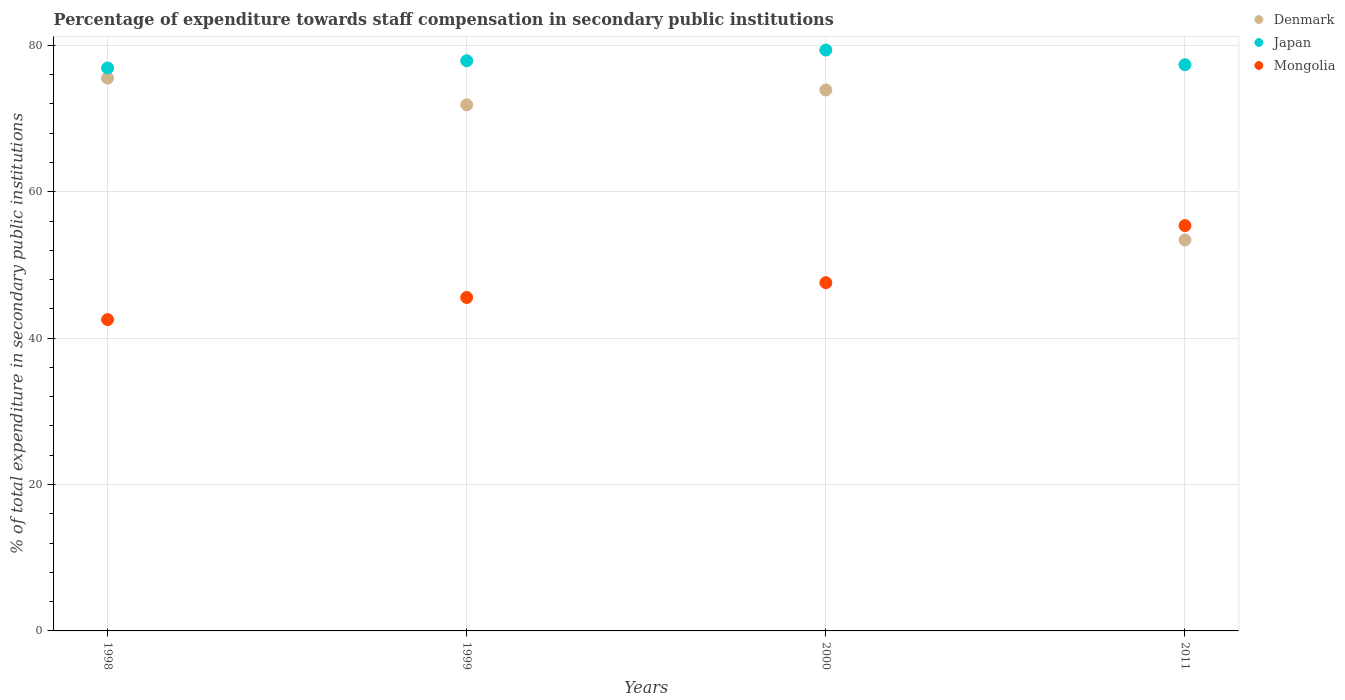What is the percentage of expenditure towards staff compensation in Denmark in 2011?
Keep it short and to the point. 53.42. Across all years, what is the maximum percentage of expenditure towards staff compensation in Mongolia?
Make the answer very short. 55.37. Across all years, what is the minimum percentage of expenditure towards staff compensation in Mongolia?
Offer a terse response. 42.53. What is the total percentage of expenditure towards staff compensation in Mongolia in the graph?
Your answer should be compact. 191.03. What is the difference between the percentage of expenditure towards staff compensation in Japan in 2000 and that in 2011?
Give a very brief answer. 2. What is the difference between the percentage of expenditure towards staff compensation in Mongolia in 1999 and the percentage of expenditure towards staff compensation in Denmark in 2000?
Your response must be concise. -28.35. What is the average percentage of expenditure towards staff compensation in Mongolia per year?
Provide a succinct answer. 47.76. In the year 2011, what is the difference between the percentage of expenditure towards staff compensation in Mongolia and percentage of expenditure towards staff compensation in Japan?
Your response must be concise. -21.99. In how many years, is the percentage of expenditure towards staff compensation in Denmark greater than 8 %?
Your response must be concise. 4. What is the ratio of the percentage of expenditure towards staff compensation in Japan in 1999 to that in 2011?
Ensure brevity in your answer.  1.01. Is the percentage of expenditure towards staff compensation in Japan in 1998 less than that in 1999?
Make the answer very short. Yes. Is the difference between the percentage of expenditure towards staff compensation in Mongolia in 1998 and 1999 greater than the difference between the percentage of expenditure towards staff compensation in Japan in 1998 and 1999?
Offer a very short reply. No. What is the difference between the highest and the second highest percentage of expenditure towards staff compensation in Denmark?
Keep it short and to the point. 1.62. What is the difference between the highest and the lowest percentage of expenditure towards staff compensation in Mongolia?
Give a very brief answer. 12.84. In how many years, is the percentage of expenditure towards staff compensation in Mongolia greater than the average percentage of expenditure towards staff compensation in Mongolia taken over all years?
Offer a terse response. 1. Is the sum of the percentage of expenditure towards staff compensation in Denmark in 1998 and 2000 greater than the maximum percentage of expenditure towards staff compensation in Mongolia across all years?
Provide a succinct answer. Yes. Is it the case that in every year, the sum of the percentage of expenditure towards staff compensation in Mongolia and percentage of expenditure towards staff compensation in Denmark  is greater than the percentage of expenditure towards staff compensation in Japan?
Keep it short and to the point. Yes. Does the percentage of expenditure towards staff compensation in Mongolia monotonically increase over the years?
Your answer should be very brief. Yes. Is the percentage of expenditure towards staff compensation in Japan strictly greater than the percentage of expenditure towards staff compensation in Mongolia over the years?
Provide a succinct answer. Yes. Is the percentage of expenditure towards staff compensation in Denmark strictly less than the percentage of expenditure towards staff compensation in Mongolia over the years?
Keep it short and to the point. No. How many years are there in the graph?
Keep it short and to the point. 4. Does the graph contain grids?
Your answer should be compact. Yes. What is the title of the graph?
Provide a succinct answer. Percentage of expenditure towards staff compensation in secondary public institutions. Does "Georgia" appear as one of the legend labels in the graph?
Offer a terse response. No. What is the label or title of the Y-axis?
Provide a succinct answer. % of total expenditure in secondary public institutions. What is the % of total expenditure in secondary public institutions in Denmark in 1998?
Your response must be concise. 75.52. What is the % of total expenditure in secondary public institutions in Japan in 1998?
Ensure brevity in your answer.  76.91. What is the % of total expenditure in secondary public institutions of Mongolia in 1998?
Give a very brief answer. 42.53. What is the % of total expenditure in secondary public institutions of Denmark in 1999?
Your answer should be very brief. 71.87. What is the % of total expenditure in secondary public institutions in Japan in 1999?
Make the answer very short. 77.89. What is the % of total expenditure in secondary public institutions in Mongolia in 1999?
Provide a short and direct response. 45.55. What is the % of total expenditure in secondary public institutions of Denmark in 2000?
Offer a very short reply. 73.9. What is the % of total expenditure in secondary public institutions of Japan in 2000?
Your response must be concise. 79.36. What is the % of total expenditure in secondary public institutions in Mongolia in 2000?
Your answer should be compact. 47.57. What is the % of total expenditure in secondary public institutions in Denmark in 2011?
Make the answer very short. 53.42. What is the % of total expenditure in secondary public institutions in Japan in 2011?
Offer a terse response. 77.36. What is the % of total expenditure in secondary public institutions in Mongolia in 2011?
Offer a terse response. 55.37. Across all years, what is the maximum % of total expenditure in secondary public institutions of Denmark?
Offer a very short reply. 75.52. Across all years, what is the maximum % of total expenditure in secondary public institutions in Japan?
Give a very brief answer. 79.36. Across all years, what is the maximum % of total expenditure in secondary public institutions of Mongolia?
Provide a short and direct response. 55.37. Across all years, what is the minimum % of total expenditure in secondary public institutions of Denmark?
Offer a terse response. 53.42. Across all years, what is the minimum % of total expenditure in secondary public institutions in Japan?
Make the answer very short. 76.91. Across all years, what is the minimum % of total expenditure in secondary public institutions in Mongolia?
Your answer should be compact. 42.53. What is the total % of total expenditure in secondary public institutions in Denmark in the graph?
Your response must be concise. 274.71. What is the total % of total expenditure in secondary public institutions in Japan in the graph?
Your answer should be very brief. 311.52. What is the total % of total expenditure in secondary public institutions in Mongolia in the graph?
Offer a very short reply. 191.03. What is the difference between the % of total expenditure in secondary public institutions of Denmark in 1998 and that in 1999?
Offer a very short reply. 3.65. What is the difference between the % of total expenditure in secondary public institutions of Japan in 1998 and that in 1999?
Offer a very short reply. -0.98. What is the difference between the % of total expenditure in secondary public institutions in Mongolia in 1998 and that in 1999?
Provide a succinct answer. -3.02. What is the difference between the % of total expenditure in secondary public institutions in Denmark in 1998 and that in 2000?
Your response must be concise. 1.62. What is the difference between the % of total expenditure in secondary public institutions of Japan in 1998 and that in 2000?
Give a very brief answer. -2.44. What is the difference between the % of total expenditure in secondary public institutions of Mongolia in 1998 and that in 2000?
Provide a succinct answer. -5.04. What is the difference between the % of total expenditure in secondary public institutions in Denmark in 1998 and that in 2011?
Make the answer very short. 22.11. What is the difference between the % of total expenditure in secondary public institutions of Japan in 1998 and that in 2011?
Give a very brief answer. -0.45. What is the difference between the % of total expenditure in secondary public institutions in Mongolia in 1998 and that in 2011?
Your response must be concise. -12.84. What is the difference between the % of total expenditure in secondary public institutions in Denmark in 1999 and that in 2000?
Give a very brief answer. -2.03. What is the difference between the % of total expenditure in secondary public institutions of Japan in 1999 and that in 2000?
Provide a succinct answer. -1.46. What is the difference between the % of total expenditure in secondary public institutions in Mongolia in 1999 and that in 2000?
Keep it short and to the point. -2.02. What is the difference between the % of total expenditure in secondary public institutions of Denmark in 1999 and that in 2011?
Provide a succinct answer. 18.46. What is the difference between the % of total expenditure in secondary public institutions of Japan in 1999 and that in 2011?
Keep it short and to the point. 0.53. What is the difference between the % of total expenditure in secondary public institutions of Mongolia in 1999 and that in 2011?
Give a very brief answer. -9.82. What is the difference between the % of total expenditure in secondary public institutions in Denmark in 2000 and that in 2011?
Make the answer very short. 20.49. What is the difference between the % of total expenditure in secondary public institutions of Japan in 2000 and that in 2011?
Make the answer very short. 2. What is the difference between the % of total expenditure in secondary public institutions of Mongolia in 2000 and that in 2011?
Your response must be concise. -7.8. What is the difference between the % of total expenditure in secondary public institutions in Denmark in 1998 and the % of total expenditure in secondary public institutions in Japan in 1999?
Offer a very short reply. -2.37. What is the difference between the % of total expenditure in secondary public institutions in Denmark in 1998 and the % of total expenditure in secondary public institutions in Mongolia in 1999?
Give a very brief answer. 29.97. What is the difference between the % of total expenditure in secondary public institutions of Japan in 1998 and the % of total expenditure in secondary public institutions of Mongolia in 1999?
Offer a very short reply. 31.36. What is the difference between the % of total expenditure in secondary public institutions in Denmark in 1998 and the % of total expenditure in secondary public institutions in Japan in 2000?
Your answer should be compact. -3.83. What is the difference between the % of total expenditure in secondary public institutions of Denmark in 1998 and the % of total expenditure in secondary public institutions of Mongolia in 2000?
Provide a succinct answer. 27.95. What is the difference between the % of total expenditure in secondary public institutions of Japan in 1998 and the % of total expenditure in secondary public institutions of Mongolia in 2000?
Your answer should be very brief. 29.34. What is the difference between the % of total expenditure in secondary public institutions in Denmark in 1998 and the % of total expenditure in secondary public institutions in Japan in 2011?
Your answer should be very brief. -1.84. What is the difference between the % of total expenditure in secondary public institutions of Denmark in 1998 and the % of total expenditure in secondary public institutions of Mongolia in 2011?
Your response must be concise. 20.15. What is the difference between the % of total expenditure in secondary public institutions in Japan in 1998 and the % of total expenditure in secondary public institutions in Mongolia in 2011?
Keep it short and to the point. 21.54. What is the difference between the % of total expenditure in secondary public institutions of Denmark in 1999 and the % of total expenditure in secondary public institutions of Japan in 2000?
Provide a succinct answer. -7.48. What is the difference between the % of total expenditure in secondary public institutions of Denmark in 1999 and the % of total expenditure in secondary public institutions of Mongolia in 2000?
Offer a terse response. 24.3. What is the difference between the % of total expenditure in secondary public institutions of Japan in 1999 and the % of total expenditure in secondary public institutions of Mongolia in 2000?
Keep it short and to the point. 30.32. What is the difference between the % of total expenditure in secondary public institutions of Denmark in 1999 and the % of total expenditure in secondary public institutions of Japan in 2011?
Your answer should be very brief. -5.49. What is the difference between the % of total expenditure in secondary public institutions of Denmark in 1999 and the % of total expenditure in secondary public institutions of Mongolia in 2011?
Your response must be concise. 16.5. What is the difference between the % of total expenditure in secondary public institutions in Japan in 1999 and the % of total expenditure in secondary public institutions in Mongolia in 2011?
Your answer should be compact. 22.52. What is the difference between the % of total expenditure in secondary public institutions in Denmark in 2000 and the % of total expenditure in secondary public institutions in Japan in 2011?
Your answer should be very brief. -3.46. What is the difference between the % of total expenditure in secondary public institutions of Denmark in 2000 and the % of total expenditure in secondary public institutions of Mongolia in 2011?
Provide a succinct answer. 18.53. What is the difference between the % of total expenditure in secondary public institutions of Japan in 2000 and the % of total expenditure in secondary public institutions of Mongolia in 2011?
Your answer should be compact. 23.98. What is the average % of total expenditure in secondary public institutions of Denmark per year?
Your response must be concise. 68.68. What is the average % of total expenditure in secondary public institutions of Japan per year?
Your answer should be compact. 77.88. What is the average % of total expenditure in secondary public institutions of Mongolia per year?
Your answer should be compact. 47.76. In the year 1998, what is the difference between the % of total expenditure in secondary public institutions in Denmark and % of total expenditure in secondary public institutions in Japan?
Your response must be concise. -1.39. In the year 1998, what is the difference between the % of total expenditure in secondary public institutions of Denmark and % of total expenditure in secondary public institutions of Mongolia?
Ensure brevity in your answer.  32.99. In the year 1998, what is the difference between the % of total expenditure in secondary public institutions of Japan and % of total expenditure in secondary public institutions of Mongolia?
Offer a very short reply. 34.38. In the year 1999, what is the difference between the % of total expenditure in secondary public institutions in Denmark and % of total expenditure in secondary public institutions in Japan?
Your response must be concise. -6.02. In the year 1999, what is the difference between the % of total expenditure in secondary public institutions of Denmark and % of total expenditure in secondary public institutions of Mongolia?
Your answer should be very brief. 26.32. In the year 1999, what is the difference between the % of total expenditure in secondary public institutions in Japan and % of total expenditure in secondary public institutions in Mongolia?
Your answer should be compact. 32.34. In the year 2000, what is the difference between the % of total expenditure in secondary public institutions in Denmark and % of total expenditure in secondary public institutions in Japan?
Provide a short and direct response. -5.45. In the year 2000, what is the difference between the % of total expenditure in secondary public institutions in Denmark and % of total expenditure in secondary public institutions in Mongolia?
Give a very brief answer. 26.33. In the year 2000, what is the difference between the % of total expenditure in secondary public institutions of Japan and % of total expenditure in secondary public institutions of Mongolia?
Provide a succinct answer. 31.78. In the year 2011, what is the difference between the % of total expenditure in secondary public institutions of Denmark and % of total expenditure in secondary public institutions of Japan?
Keep it short and to the point. -23.94. In the year 2011, what is the difference between the % of total expenditure in secondary public institutions in Denmark and % of total expenditure in secondary public institutions in Mongolia?
Keep it short and to the point. -1.95. In the year 2011, what is the difference between the % of total expenditure in secondary public institutions in Japan and % of total expenditure in secondary public institutions in Mongolia?
Provide a short and direct response. 21.99. What is the ratio of the % of total expenditure in secondary public institutions in Denmark in 1998 to that in 1999?
Your answer should be compact. 1.05. What is the ratio of the % of total expenditure in secondary public institutions in Japan in 1998 to that in 1999?
Your response must be concise. 0.99. What is the ratio of the % of total expenditure in secondary public institutions of Mongolia in 1998 to that in 1999?
Provide a short and direct response. 0.93. What is the ratio of the % of total expenditure in secondary public institutions in Denmark in 1998 to that in 2000?
Your answer should be very brief. 1.02. What is the ratio of the % of total expenditure in secondary public institutions in Japan in 1998 to that in 2000?
Provide a succinct answer. 0.97. What is the ratio of the % of total expenditure in secondary public institutions of Mongolia in 1998 to that in 2000?
Your response must be concise. 0.89. What is the ratio of the % of total expenditure in secondary public institutions of Denmark in 1998 to that in 2011?
Provide a short and direct response. 1.41. What is the ratio of the % of total expenditure in secondary public institutions of Japan in 1998 to that in 2011?
Provide a succinct answer. 0.99. What is the ratio of the % of total expenditure in secondary public institutions of Mongolia in 1998 to that in 2011?
Provide a succinct answer. 0.77. What is the ratio of the % of total expenditure in secondary public institutions in Denmark in 1999 to that in 2000?
Ensure brevity in your answer.  0.97. What is the ratio of the % of total expenditure in secondary public institutions of Japan in 1999 to that in 2000?
Make the answer very short. 0.98. What is the ratio of the % of total expenditure in secondary public institutions of Mongolia in 1999 to that in 2000?
Ensure brevity in your answer.  0.96. What is the ratio of the % of total expenditure in secondary public institutions in Denmark in 1999 to that in 2011?
Provide a succinct answer. 1.35. What is the ratio of the % of total expenditure in secondary public institutions of Mongolia in 1999 to that in 2011?
Offer a terse response. 0.82. What is the ratio of the % of total expenditure in secondary public institutions of Denmark in 2000 to that in 2011?
Offer a very short reply. 1.38. What is the ratio of the % of total expenditure in secondary public institutions in Japan in 2000 to that in 2011?
Provide a short and direct response. 1.03. What is the ratio of the % of total expenditure in secondary public institutions of Mongolia in 2000 to that in 2011?
Keep it short and to the point. 0.86. What is the difference between the highest and the second highest % of total expenditure in secondary public institutions of Denmark?
Give a very brief answer. 1.62. What is the difference between the highest and the second highest % of total expenditure in secondary public institutions in Japan?
Make the answer very short. 1.46. What is the difference between the highest and the second highest % of total expenditure in secondary public institutions of Mongolia?
Offer a very short reply. 7.8. What is the difference between the highest and the lowest % of total expenditure in secondary public institutions of Denmark?
Offer a very short reply. 22.11. What is the difference between the highest and the lowest % of total expenditure in secondary public institutions in Japan?
Your response must be concise. 2.44. What is the difference between the highest and the lowest % of total expenditure in secondary public institutions in Mongolia?
Give a very brief answer. 12.84. 